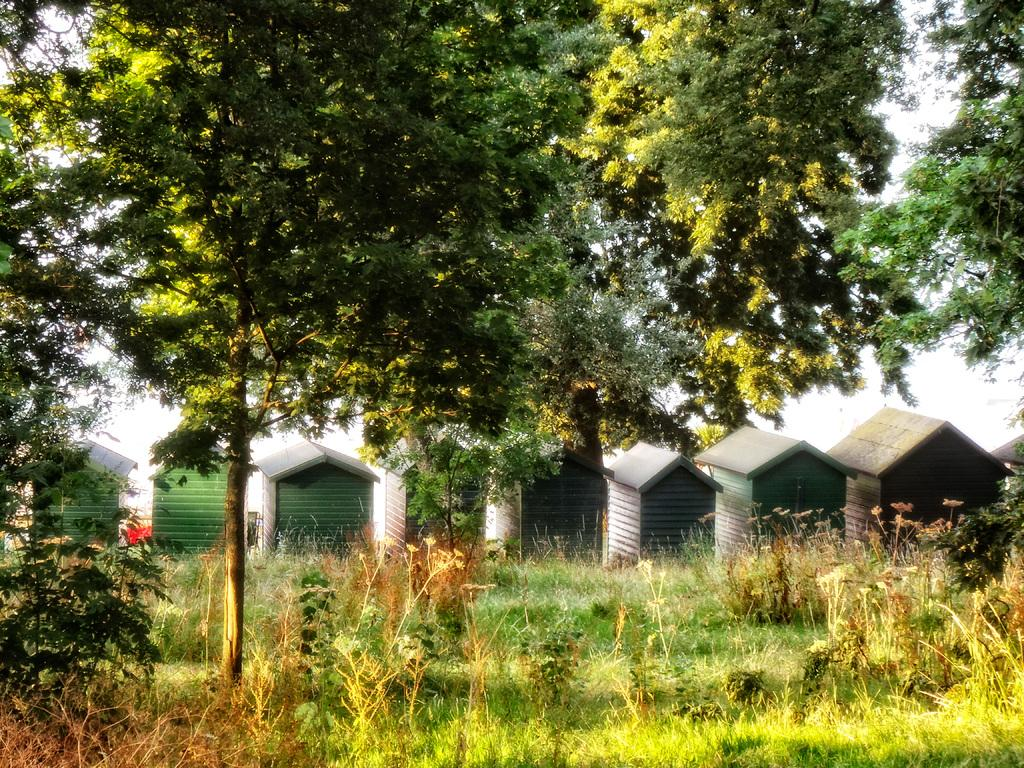What type of vegetation can be seen in the image? There are plants and trees in the image. What type of structures are present in the image? There are sheds in the image. What is visible in the background of the image? The sky is visible in the image. How many visitors are present in the image? There is no indication of any visitors in the image. What type of box can be seen in the image? There is no box present in the image. 